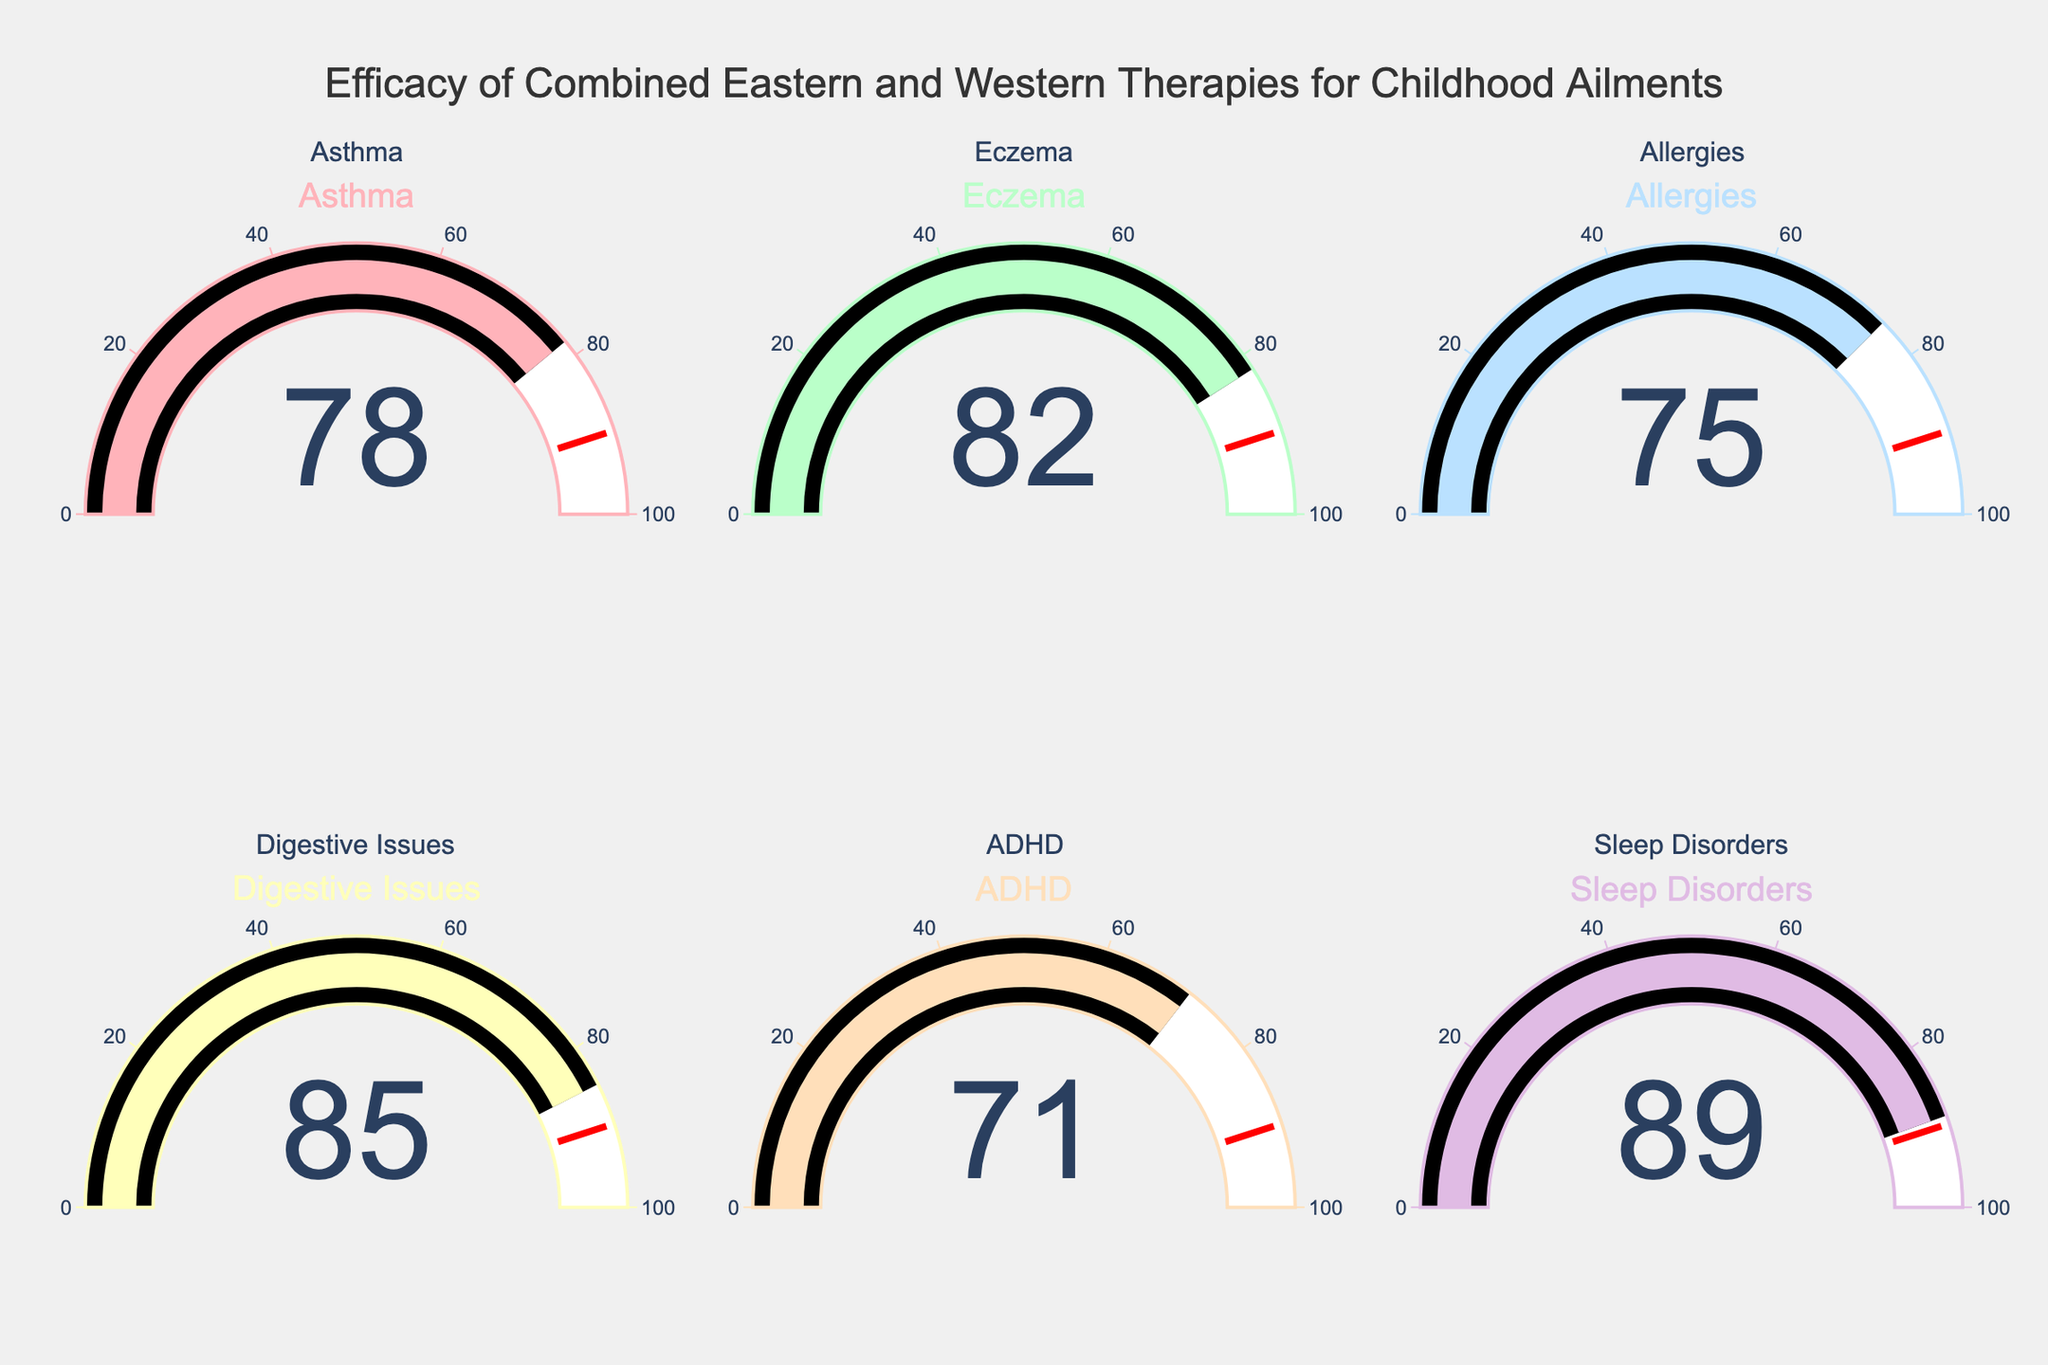What is the efficacy rate for Digestive Issues? The gauge chart for Digestive Issues shows a value. Refer to the gauge showing Digestive Issues to find the number displayed.
Answer: 85 Which ailment has the highest efficacy rate? Compare all the values displayed on the gauges. The highest value will be the highest efficacy rate.
Answer: Sleep Disorders How many ailments have an efficacy rate above 80? Count the number of gauge charts with values greater than 80. Check each chart and count the qualifying values.
Answer: 4 What is the average efficacy rate for all the ailments? Sum all the efficacy rates and divide by the number of ailments. Calculation: (78 + 82 + 75 + 85 + 71 + 89) / 6 = 480 / 6 = 80
Answer: 80 What is the difference in efficacy rates between ADHD and Allergies? Subtract the efficacy rate for ADHD from the efficacy rate for Allergies. Calculation: 75 - 71 = 4
Answer: 4 Which has a higher efficacy rate, Asthma or Eczema? Compare the efficacy rates for Asthma and Eczema. Identify which value is larger.
Answer: Eczema Is there any ailment with an efficacy rate lower than 70? Check all the gauges. Determine if any value is below 70.
Answer: No Which ailment has the lowest efficacy rate? Identify the gauge chart with the smallest value.
Answer: ADHD What is the median efficacy rate of the six ailments? Order the efficacy rates and find the middle value. For even numbers of data points, average the two middle values. Ordered rates: 71, 75, 78, 82, 85, 89. Median calculation: (78 + 82) / 2 = 160 / 2 = 80
Answer: 80 If the efficacy rate for Asthma increased by 5 points, what would the new average efficacy rate be? Add 5 points to the Asthma rate, then calculate the new average. New sum: 83 + 82 + 75 + 85 + 71 + 89 = 485. New average: 485 / 6 = 80.83
Answer: 80.83 